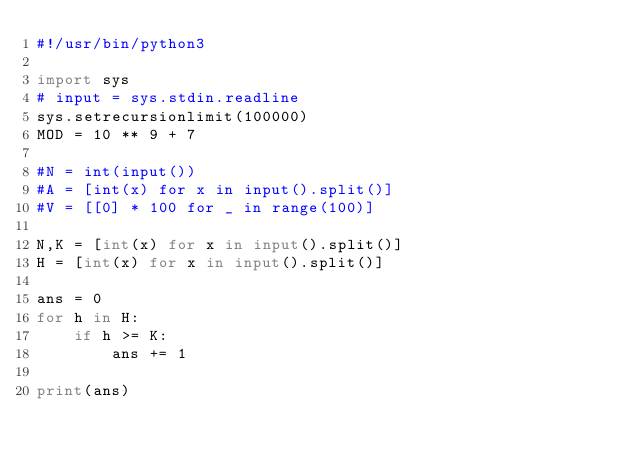<code> <loc_0><loc_0><loc_500><loc_500><_Python_>#!/usr/bin/python3

import sys
# input = sys.stdin.readline
sys.setrecursionlimit(100000)
MOD = 10 ** 9 + 7

#N = int(input())
#A = [int(x) for x in input().split()]
#V = [[0] * 100 for _ in range(100)]

N,K = [int(x) for x in input().split()]
H = [int(x) for x in input().split()]

ans = 0
for h in H:
    if h >= K:
        ans += 1

print(ans)</code> 